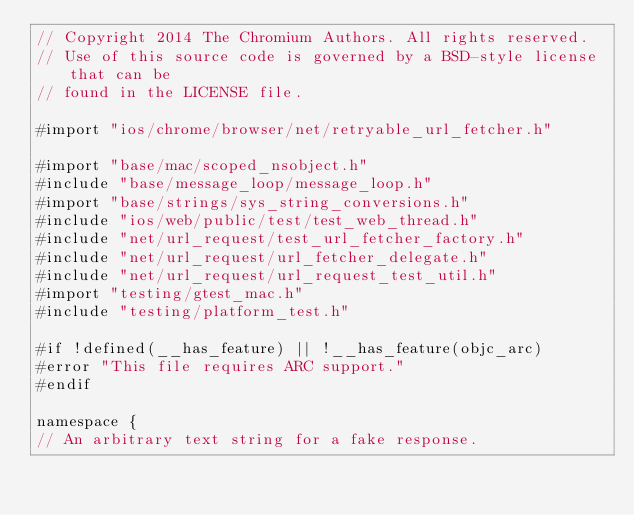Convert code to text. <code><loc_0><loc_0><loc_500><loc_500><_ObjectiveC_>// Copyright 2014 The Chromium Authors. All rights reserved.
// Use of this source code is governed by a BSD-style license that can be
// found in the LICENSE file.

#import "ios/chrome/browser/net/retryable_url_fetcher.h"

#import "base/mac/scoped_nsobject.h"
#include "base/message_loop/message_loop.h"
#import "base/strings/sys_string_conversions.h"
#include "ios/web/public/test/test_web_thread.h"
#include "net/url_request/test_url_fetcher_factory.h"
#include "net/url_request/url_fetcher_delegate.h"
#include "net/url_request/url_request_test_util.h"
#import "testing/gtest_mac.h"
#include "testing/platform_test.h"

#if !defined(__has_feature) || !__has_feature(objc_arc)
#error "This file requires ARC support."
#endif

namespace {
// An arbitrary text string for a fake response.</code> 